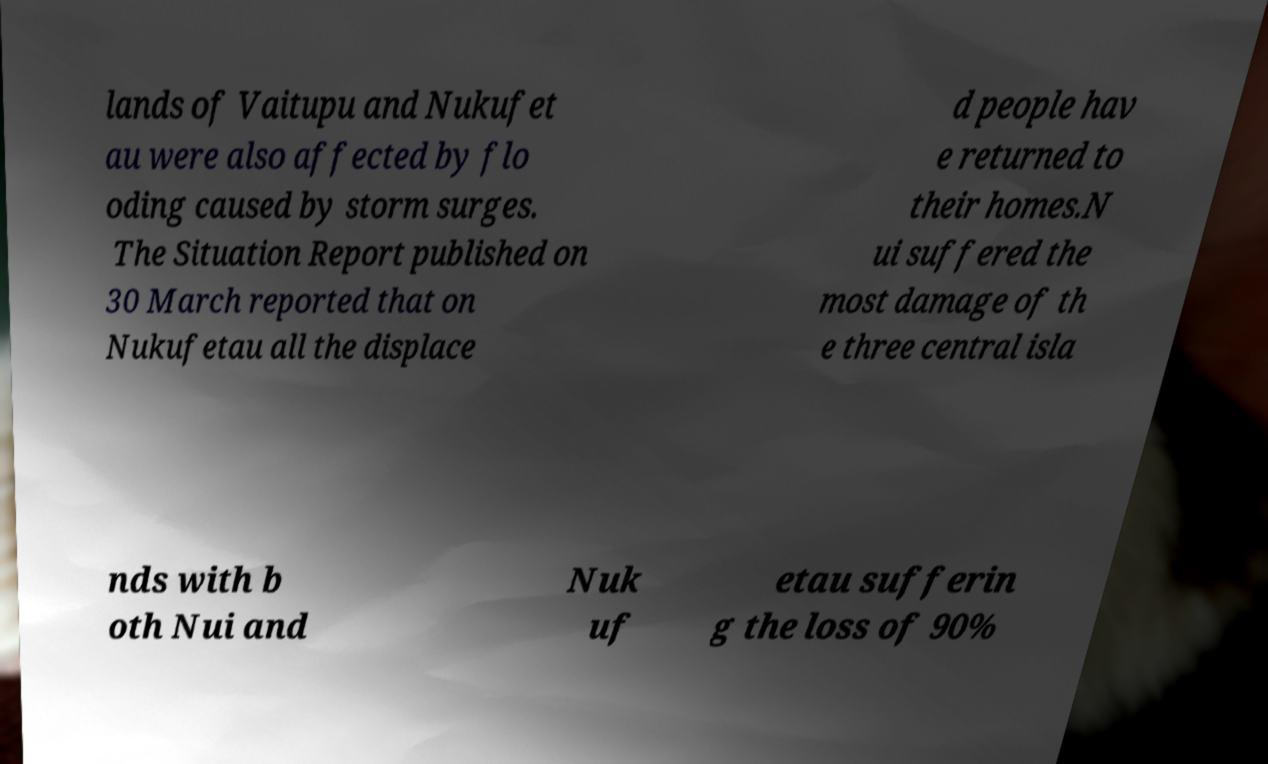I need the written content from this picture converted into text. Can you do that? lands of Vaitupu and Nukufet au were also affected by flo oding caused by storm surges. The Situation Report published on 30 March reported that on Nukufetau all the displace d people hav e returned to their homes.N ui suffered the most damage of th e three central isla nds with b oth Nui and Nuk uf etau sufferin g the loss of 90% 